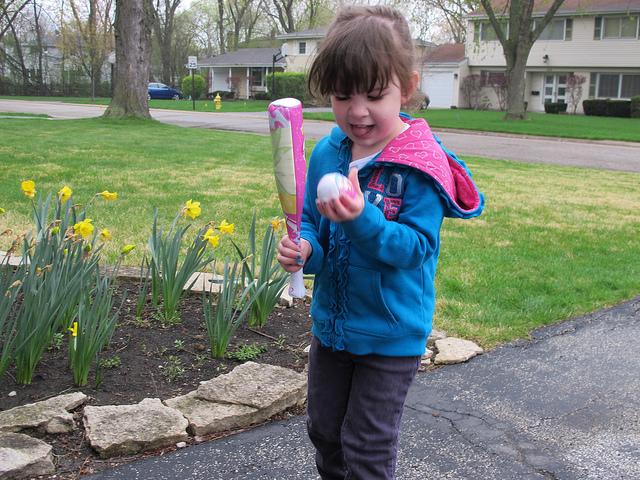What is the child holding?
Answer briefly. Bat and ball. What type of flowers are in the picture?
Be succinct. Daffodils. What kind of top is the girl wearing?
Keep it brief. Jacket. 